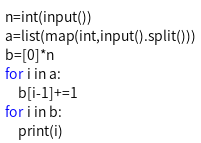Convert code to text. <code><loc_0><loc_0><loc_500><loc_500><_Python_>n=int(input())
a=list(map(int,input().split()))
b=[0]*n
for i in a:
    b[i-1]+=1
for i in b:
    print(i)</code> 